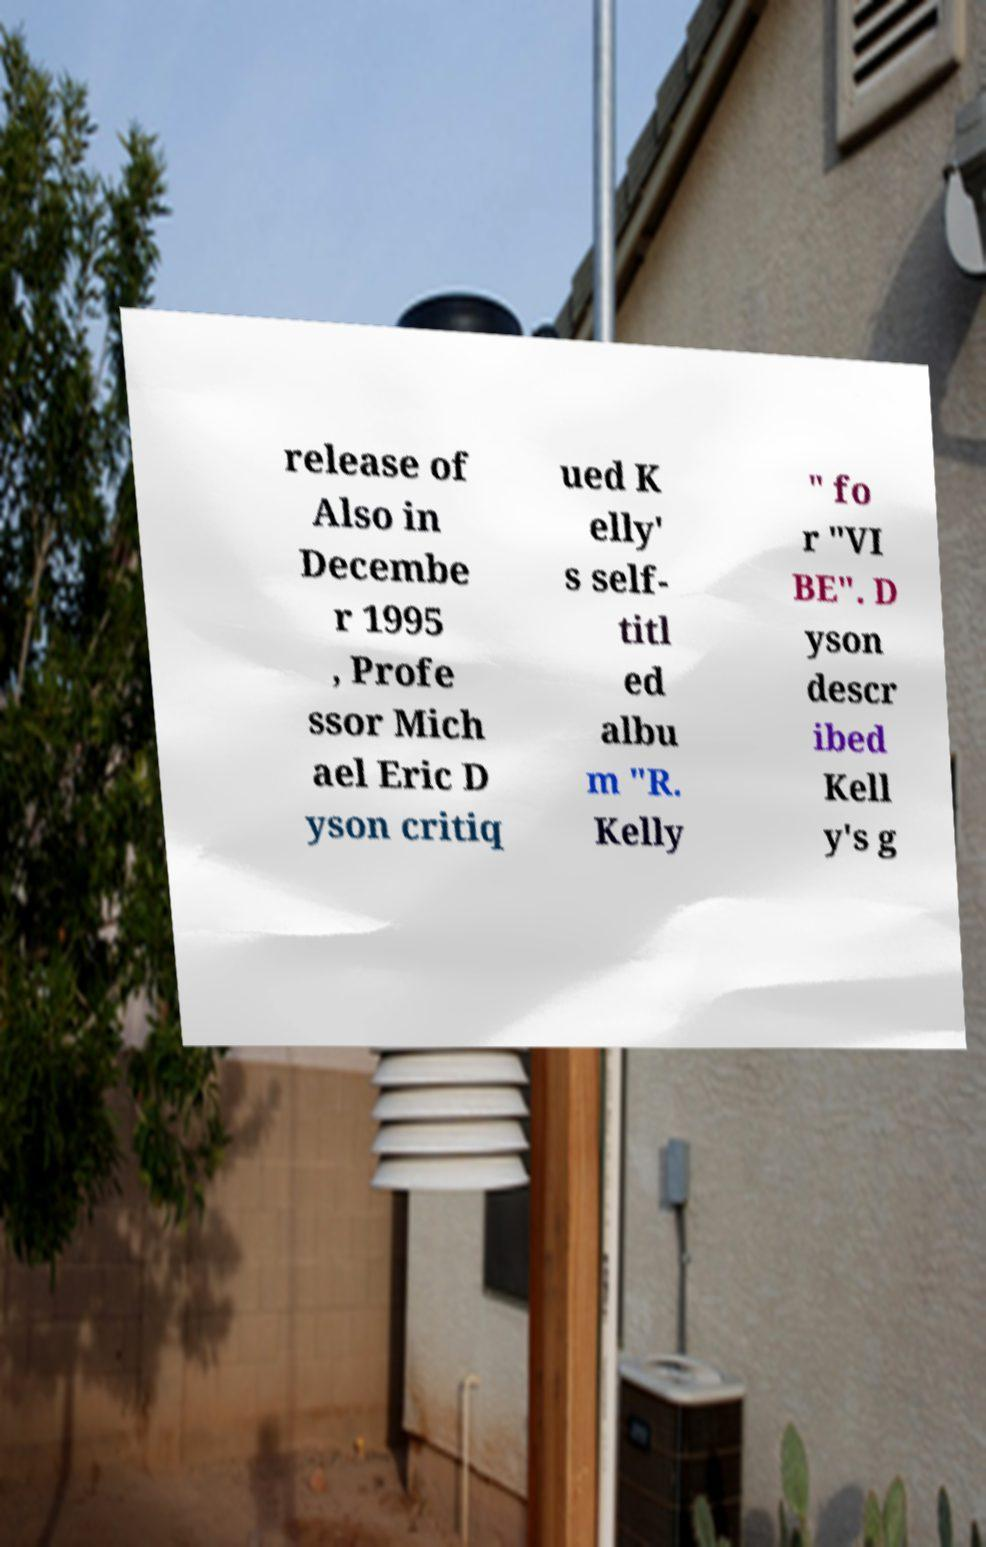There's text embedded in this image that I need extracted. Can you transcribe it verbatim? release of Also in Decembe r 1995 , Profe ssor Mich ael Eric D yson critiq ued K elly' s self- titl ed albu m "R. Kelly " fo r "VI BE". D yson descr ibed Kell y's g 